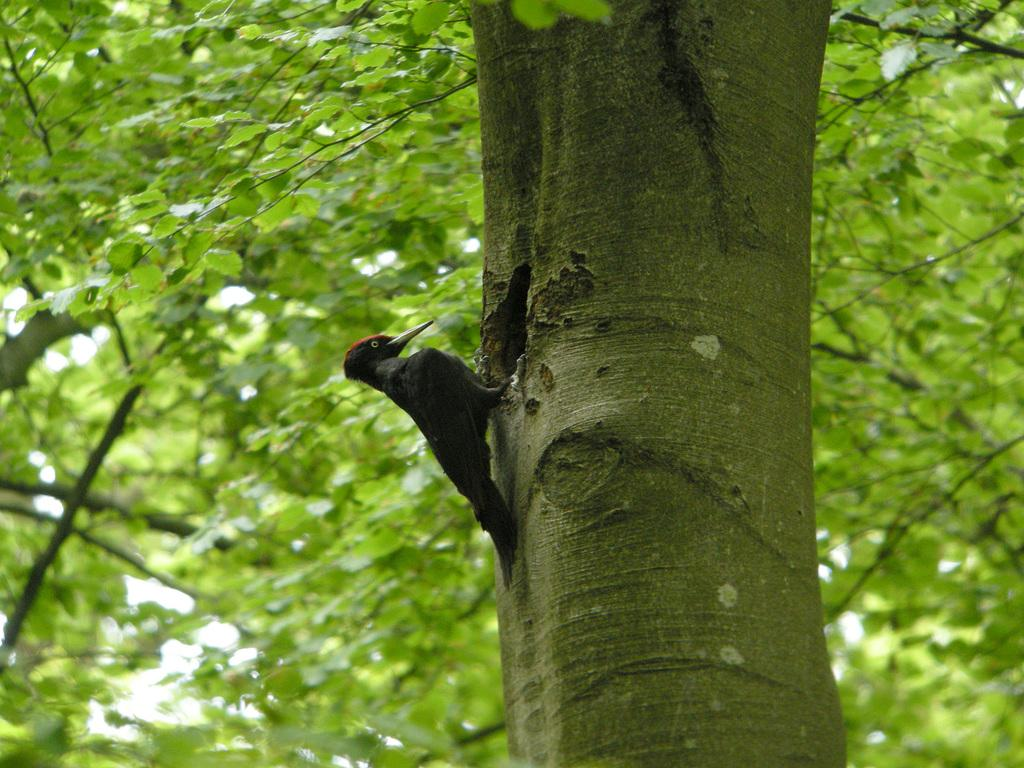What is the main subject in the middle of the image? There is a bird in the middle of the image. What can be seen in the background of the image? There are trees in the background of the image. What type of silk is being used to create the bird's neck in the image? There is no silk or mention of a neck in the image; it features a bird with a natural neck. 